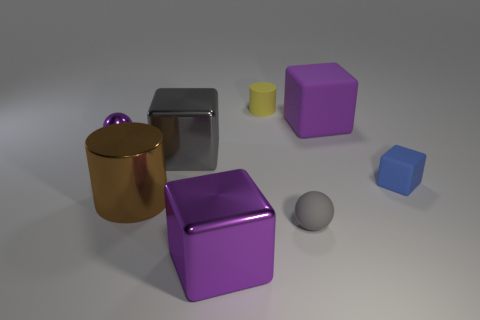The blue rubber block has what size?
Your answer should be compact. Small. Do the small ball left of the yellow rubber cylinder and the small cube have the same material?
Offer a terse response. No. How many tiny yellow objects are there?
Keep it short and to the point. 1. How many things are small blue objects or matte cubes?
Your response must be concise. 2. What number of gray matte balls are to the left of the purple object in front of the small sphere that is behind the rubber sphere?
Your answer should be very brief. 0. Is there any other thing that is the same color as the tiny rubber block?
Your response must be concise. No. There is a big metallic thing that is behind the small block; is its color the same as the large thing in front of the gray matte thing?
Keep it short and to the point. No. Are there more small rubber cylinders that are to the left of the big brown cylinder than metallic balls in front of the purple metal sphere?
Your answer should be very brief. No. What is the brown thing made of?
Make the answer very short. Metal. There is a purple metal object in front of the gray object that is on the left side of the cube that is in front of the tiny gray ball; what shape is it?
Make the answer very short. Cube. 